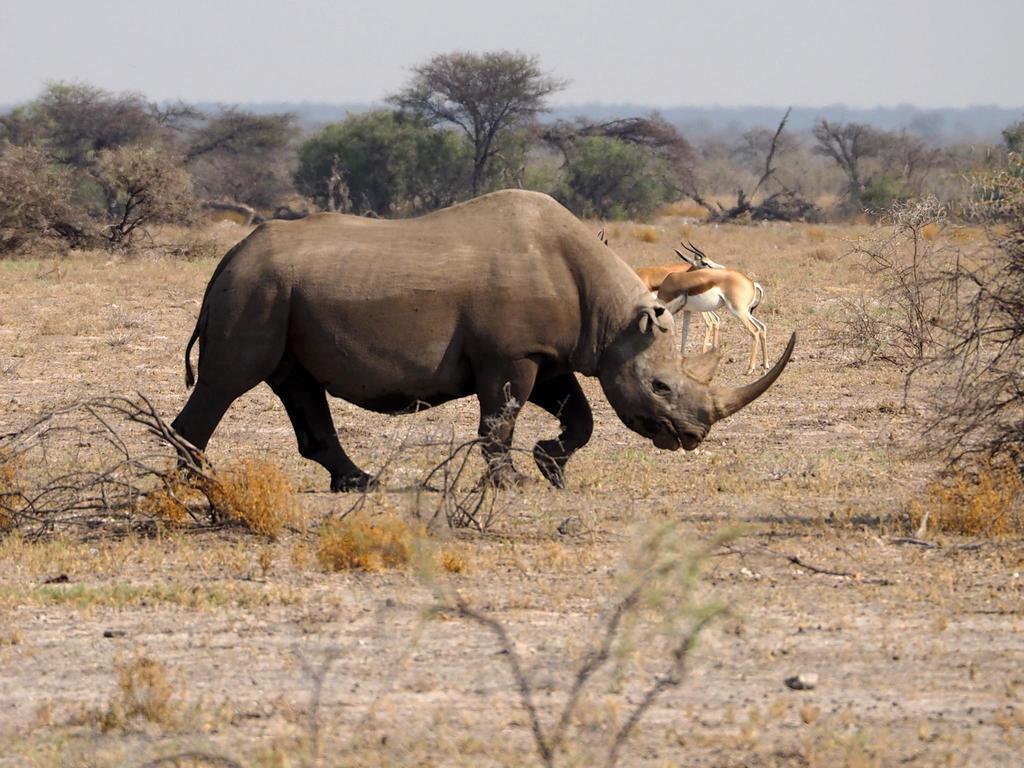Can you describe this image briefly? In this image we can see the animals. Behind the animals we can see a group of trees. In the foreground we can see the twigs. At the top we can see the sky. 